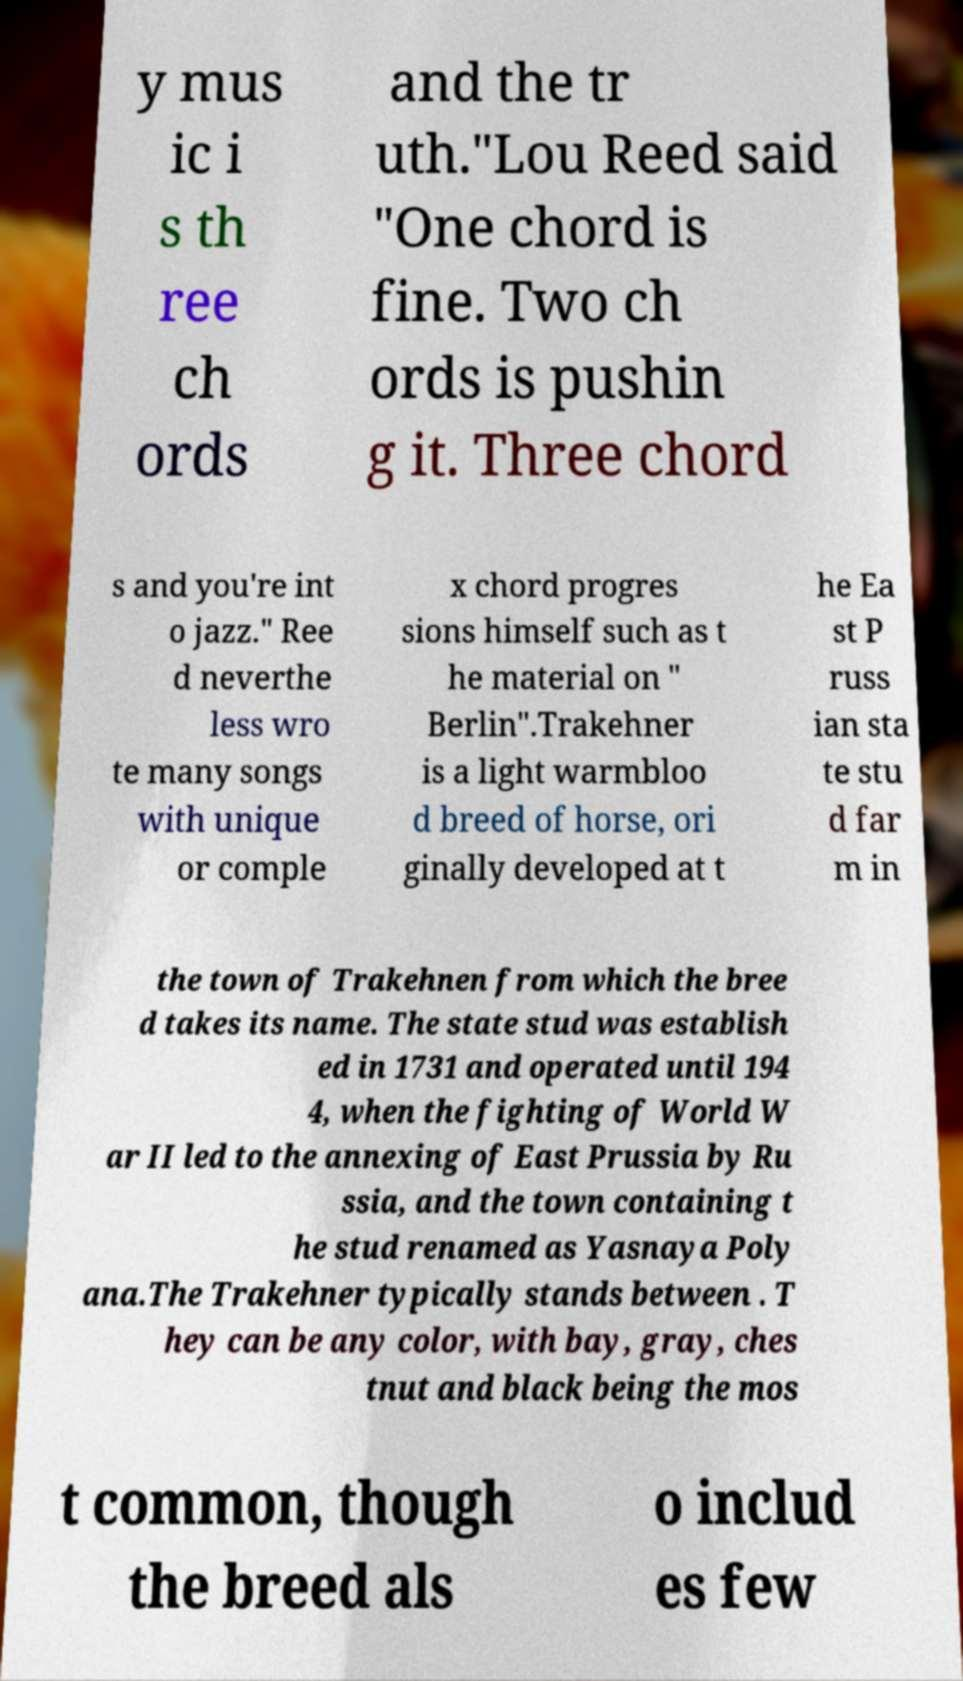For documentation purposes, I need the text within this image transcribed. Could you provide that? y mus ic i s th ree ch ords and the tr uth."Lou Reed said "One chord is fine. Two ch ords is pushin g it. Three chord s and you're int o jazz." Ree d neverthe less wro te many songs with unique or comple x chord progres sions himself such as t he material on " Berlin".Trakehner is a light warmbloo d breed of horse, ori ginally developed at t he Ea st P russ ian sta te stu d far m in the town of Trakehnen from which the bree d takes its name. The state stud was establish ed in 1731 and operated until 194 4, when the fighting of World W ar II led to the annexing of East Prussia by Ru ssia, and the town containing t he stud renamed as Yasnaya Poly ana.The Trakehner typically stands between . T hey can be any color, with bay, gray, ches tnut and black being the mos t common, though the breed als o includ es few 